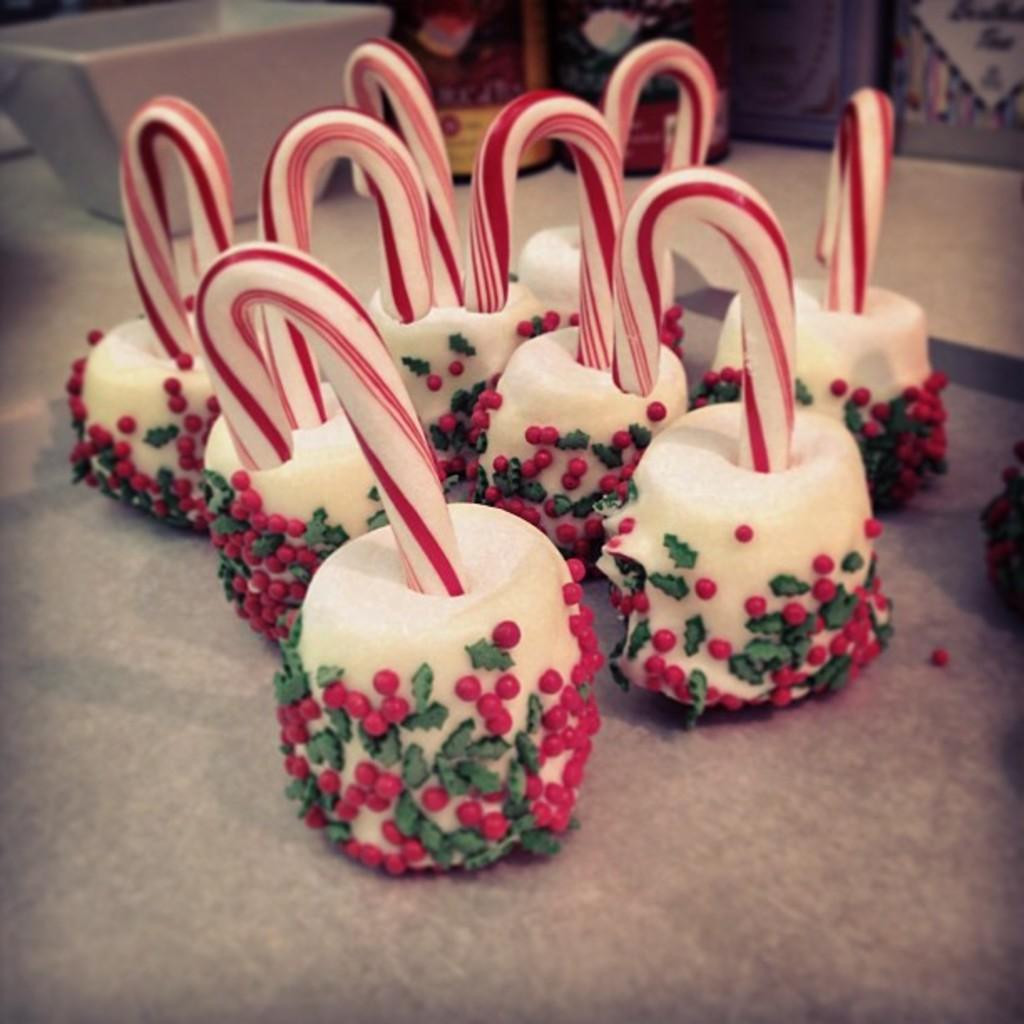What objects are present in the image that involve light or heat? There are candles on an object in the image. What can be found at the top of the image? There is a bowl at the top of the image. What is the name of the country where the candles were made? There is no information about the country of origin for the candles in the image. What type of cloth is used to cover the bowl in the image? There is no cloth covering the bowl in the image. 